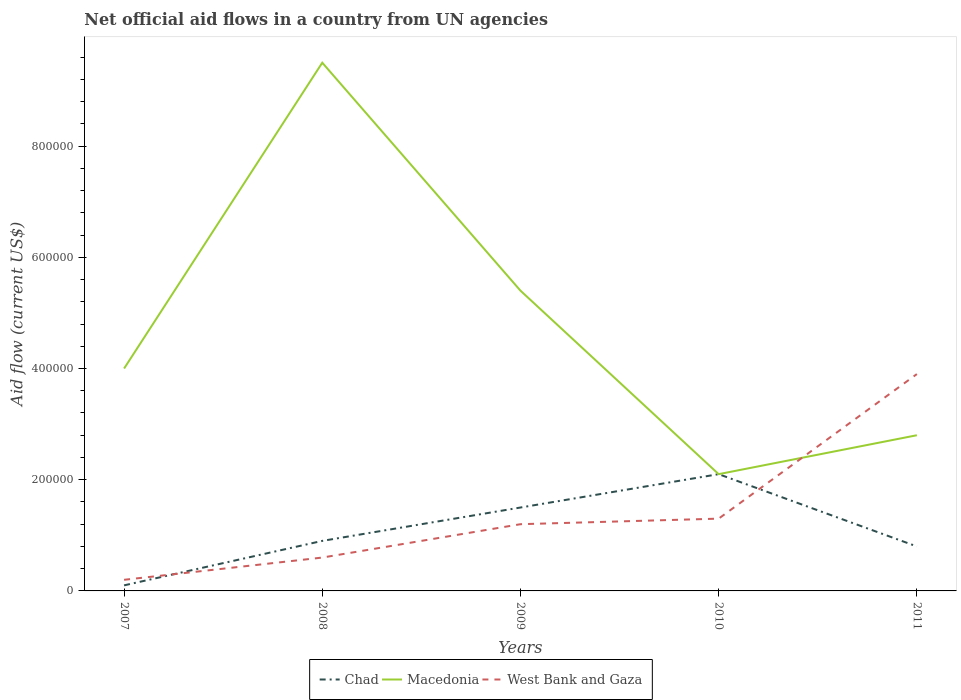How many different coloured lines are there?
Provide a short and direct response. 3. Does the line corresponding to Macedonia intersect with the line corresponding to Chad?
Provide a succinct answer. Yes. Is the number of lines equal to the number of legend labels?
Your answer should be compact. Yes. Across all years, what is the maximum net official aid flow in West Bank and Gaza?
Make the answer very short. 2.00e+04. In which year was the net official aid flow in Chad maximum?
Your answer should be compact. 2007. What is the total net official aid flow in West Bank and Gaza in the graph?
Your answer should be compact. -2.60e+05. What is the difference between the highest and the second highest net official aid flow in West Bank and Gaza?
Make the answer very short. 3.70e+05. What is the difference between the highest and the lowest net official aid flow in Chad?
Your response must be concise. 2. Is the net official aid flow in Chad strictly greater than the net official aid flow in Macedonia over the years?
Keep it short and to the point. No. What is the difference between two consecutive major ticks on the Y-axis?
Provide a short and direct response. 2.00e+05. Are the values on the major ticks of Y-axis written in scientific E-notation?
Ensure brevity in your answer.  No. Does the graph contain grids?
Provide a short and direct response. No. How many legend labels are there?
Provide a short and direct response. 3. How are the legend labels stacked?
Give a very brief answer. Horizontal. What is the title of the graph?
Offer a very short reply. Net official aid flows in a country from UN agencies. Does "Guyana" appear as one of the legend labels in the graph?
Your answer should be very brief. No. What is the Aid flow (current US$) of Chad in 2007?
Give a very brief answer. 10000. What is the Aid flow (current US$) of Macedonia in 2007?
Your response must be concise. 4.00e+05. What is the Aid flow (current US$) of West Bank and Gaza in 2007?
Give a very brief answer. 2.00e+04. What is the Aid flow (current US$) in Chad in 2008?
Your answer should be very brief. 9.00e+04. What is the Aid flow (current US$) of Macedonia in 2008?
Offer a very short reply. 9.50e+05. What is the Aid flow (current US$) of Chad in 2009?
Ensure brevity in your answer.  1.50e+05. What is the Aid flow (current US$) in Macedonia in 2009?
Keep it short and to the point. 5.40e+05. What is the Aid flow (current US$) in West Bank and Gaza in 2009?
Provide a succinct answer. 1.20e+05. What is the Aid flow (current US$) in Chad in 2010?
Your answer should be very brief. 2.10e+05. What is the Aid flow (current US$) in West Bank and Gaza in 2010?
Give a very brief answer. 1.30e+05. What is the Aid flow (current US$) of Chad in 2011?
Your answer should be compact. 8.00e+04. What is the Aid flow (current US$) of Macedonia in 2011?
Your answer should be very brief. 2.80e+05. What is the Aid flow (current US$) of West Bank and Gaza in 2011?
Your answer should be very brief. 3.90e+05. Across all years, what is the maximum Aid flow (current US$) in Chad?
Offer a very short reply. 2.10e+05. Across all years, what is the maximum Aid flow (current US$) in Macedonia?
Ensure brevity in your answer.  9.50e+05. Across all years, what is the maximum Aid flow (current US$) of West Bank and Gaza?
Ensure brevity in your answer.  3.90e+05. Across all years, what is the minimum Aid flow (current US$) in Chad?
Your response must be concise. 10000. Across all years, what is the minimum Aid flow (current US$) in Macedonia?
Provide a succinct answer. 2.10e+05. Across all years, what is the minimum Aid flow (current US$) in West Bank and Gaza?
Provide a short and direct response. 2.00e+04. What is the total Aid flow (current US$) in Chad in the graph?
Keep it short and to the point. 5.40e+05. What is the total Aid flow (current US$) in Macedonia in the graph?
Ensure brevity in your answer.  2.38e+06. What is the total Aid flow (current US$) in West Bank and Gaza in the graph?
Offer a very short reply. 7.20e+05. What is the difference between the Aid flow (current US$) of Chad in 2007 and that in 2008?
Keep it short and to the point. -8.00e+04. What is the difference between the Aid flow (current US$) of Macedonia in 2007 and that in 2008?
Your answer should be compact. -5.50e+05. What is the difference between the Aid flow (current US$) of Macedonia in 2007 and that in 2009?
Give a very brief answer. -1.40e+05. What is the difference between the Aid flow (current US$) in West Bank and Gaza in 2007 and that in 2009?
Your answer should be compact. -1.00e+05. What is the difference between the Aid flow (current US$) in Macedonia in 2007 and that in 2010?
Your answer should be compact. 1.90e+05. What is the difference between the Aid flow (current US$) of Chad in 2007 and that in 2011?
Make the answer very short. -7.00e+04. What is the difference between the Aid flow (current US$) in West Bank and Gaza in 2007 and that in 2011?
Your answer should be compact. -3.70e+05. What is the difference between the Aid flow (current US$) of Chad in 2008 and that in 2009?
Your response must be concise. -6.00e+04. What is the difference between the Aid flow (current US$) in Macedonia in 2008 and that in 2009?
Make the answer very short. 4.10e+05. What is the difference between the Aid flow (current US$) in Chad in 2008 and that in 2010?
Provide a succinct answer. -1.20e+05. What is the difference between the Aid flow (current US$) of Macedonia in 2008 and that in 2010?
Provide a short and direct response. 7.40e+05. What is the difference between the Aid flow (current US$) of Chad in 2008 and that in 2011?
Your answer should be compact. 10000. What is the difference between the Aid flow (current US$) in Macedonia in 2008 and that in 2011?
Keep it short and to the point. 6.70e+05. What is the difference between the Aid flow (current US$) in West Bank and Gaza in 2008 and that in 2011?
Your answer should be very brief. -3.30e+05. What is the difference between the Aid flow (current US$) in Macedonia in 2009 and that in 2011?
Offer a very short reply. 2.60e+05. What is the difference between the Aid flow (current US$) in Chad in 2007 and the Aid flow (current US$) in Macedonia in 2008?
Make the answer very short. -9.40e+05. What is the difference between the Aid flow (current US$) of Chad in 2007 and the Aid flow (current US$) of Macedonia in 2009?
Provide a succinct answer. -5.30e+05. What is the difference between the Aid flow (current US$) in Chad in 2007 and the Aid flow (current US$) in West Bank and Gaza in 2010?
Give a very brief answer. -1.20e+05. What is the difference between the Aid flow (current US$) of Macedonia in 2007 and the Aid flow (current US$) of West Bank and Gaza in 2010?
Offer a very short reply. 2.70e+05. What is the difference between the Aid flow (current US$) in Chad in 2007 and the Aid flow (current US$) in Macedonia in 2011?
Keep it short and to the point. -2.70e+05. What is the difference between the Aid flow (current US$) of Chad in 2007 and the Aid flow (current US$) of West Bank and Gaza in 2011?
Give a very brief answer. -3.80e+05. What is the difference between the Aid flow (current US$) in Macedonia in 2007 and the Aid flow (current US$) in West Bank and Gaza in 2011?
Make the answer very short. 10000. What is the difference between the Aid flow (current US$) of Chad in 2008 and the Aid flow (current US$) of Macedonia in 2009?
Offer a terse response. -4.50e+05. What is the difference between the Aid flow (current US$) of Macedonia in 2008 and the Aid flow (current US$) of West Bank and Gaza in 2009?
Provide a succinct answer. 8.30e+05. What is the difference between the Aid flow (current US$) in Chad in 2008 and the Aid flow (current US$) in West Bank and Gaza in 2010?
Offer a very short reply. -4.00e+04. What is the difference between the Aid flow (current US$) in Macedonia in 2008 and the Aid flow (current US$) in West Bank and Gaza in 2010?
Offer a terse response. 8.20e+05. What is the difference between the Aid flow (current US$) in Macedonia in 2008 and the Aid flow (current US$) in West Bank and Gaza in 2011?
Your answer should be compact. 5.60e+05. What is the difference between the Aid flow (current US$) of Chad in 2009 and the Aid flow (current US$) of Macedonia in 2010?
Provide a short and direct response. -6.00e+04. What is the difference between the Aid flow (current US$) in Chad in 2009 and the Aid flow (current US$) in Macedonia in 2011?
Your answer should be very brief. -1.30e+05. What is the difference between the Aid flow (current US$) of Chad in 2010 and the Aid flow (current US$) of Macedonia in 2011?
Provide a short and direct response. -7.00e+04. What is the average Aid flow (current US$) of Chad per year?
Keep it short and to the point. 1.08e+05. What is the average Aid flow (current US$) of Macedonia per year?
Ensure brevity in your answer.  4.76e+05. What is the average Aid flow (current US$) of West Bank and Gaza per year?
Provide a short and direct response. 1.44e+05. In the year 2007, what is the difference between the Aid flow (current US$) of Chad and Aid flow (current US$) of Macedonia?
Your answer should be compact. -3.90e+05. In the year 2007, what is the difference between the Aid flow (current US$) in Macedonia and Aid flow (current US$) in West Bank and Gaza?
Offer a terse response. 3.80e+05. In the year 2008, what is the difference between the Aid flow (current US$) in Chad and Aid flow (current US$) in Macedonia?
Give a very brief answer. -8.60e+05. In the year 2008, what is the difference between the Aid flow (current US$) of Macedonia and Aid flow (current US$) of West Bank and Gaza?
Ensure brevity in your answer.  8.90e+05. In the year 2009, what is the difference between the Aid flow (current US$) of Chad and Aid flow (current US$) of Macedonia?
Ensure brevity in your answer.  -3.90e+05. In the year 2010, what is the difference between the Aid flow (current US$) in Chad and Aid flow (current US$) in Macedonia?
Offer a terse response. 0. In the year 2010, what is the difference between the Aid flow (current US$) of Chad and Aid flow (current US$) of West Bank and Gaza?
Offer a terse response. 8.00e+04. In the year 2010, what is the difference between the Aid flow (current US$) of Macedonia and Aid flow (current US$) of West Bank and Gaza?
Provide a short and direct response. 8.00e+04. In the year 2011, what is the difference between the Aid flow (current US$) of Chad and Aid flow (current US$) of Macedonia?
Give a very brief answer. -2.00e+05. In the year 2011, what is the difference between the Aid flow (current US$) in Chad and Aid flow (current US$) in West Bank and Gaza?
Your answer should be compact. -3.10e+05. What is the ratio of the Aid flow (current US$) of Chad in 2007 to that in 2008?
Provide a succinct answer. 0.11. What is the ratio of the Aid flow (current US$) of Macedonia in 2007 to that in 2008?
Keep it short and to the point. 0.42. What is the ratio of the Aid flow (current US$) in Chad in 2007 to that in 2009?
Your response must be concise. 0.07. What is the ratio of the Aid flow (current US$) in Macedonia in 2007 to that in 2009?
Keep it short and to the point. 0.74. What is the ratio of the Aid flow (current US$) in Chad in 2007 to that in 2010?
Ensure brevity in your answer.  0.05. What is the ratio of the Aid flow (current US$) in Macedonia in 2007 to that in 2010?
Offer a terse response. 1.9. What is the ratio of the Aid flow (current US$) of West Bank and Gaza in 2007 to that in 2010?
Offer a terse response. 0.15. What is the ratio of the Aid flow (current US$) of Macedonia in 2007 to that in 2011?
Your response must be concise. 1.43. What is the ratio of the Aid flow (current US$) in West Bank and Gaza in 2007 to that in 2011?
Your response must be concise. 0.05. What is the ratio of the Aid flow (current US$) of Chad in 2008 to that in 2009?
Your answer should be very brief. 0.6. What is the ratio of the Aid flow (current US$) of Macedonia in 2008 to that in 2009?
Provide a short and direct response. 1.76. What is the ratio of the Aid flow (current US$) of Chad in 2008 to that in 2010?
Make the answer very short. 0.43. What is the ratio of the Aid flow (current US$) of Macedonia in 2008 to that in 2010?
Provide a short and direct response. 4.52. What is the ratio of the Aid flow (current US$) in West Bank and Gaza in 2008 to that in 2010?
Provide a succinct answer. 0.46. What is the ratio of the Aid flow (current US$) of Chad in 2008 to that in 2011?
Provide a succinct answer. 1.12. What is the ratio of the Aid flow (current US$) in Macedonia in 2008 to that in 2011?
Make the answer very short. 3.39. What is the ratio of the Aid flow (current US$) in West Bank and Gaza in 2008 to that in 2011?
Make the answer very short. 0.15. What is the ratio of the Aid flow (current US$) of Chad in 2009 to that in 2010?
Offer a terse response. 0.71. What is the ratio of the Aid flow (current US$) of Macedonia in 2009 to that in 2010?
Offer a very short reply. 2.57. What is the ratio of the Aid flow (current US$) in West Bank and Gaza in 2009 to that in 2010?
Provide a succinct answer. 0.92. What is the ratio of the Aid flow (current US$) of Chad in 2009 to that in 2011?
Keep it short and to the point. 1.88. What is the ratio of the Aid flow (current US$) in Macedonia in 2009 to that in 2011?
Offer a terse response. 1.93. What is the ratio of the Aid flow (current US$) of West Bank and Gaza in 2009 to that in 2011?
Provide a succinct answer. 0.31. What is the ratio of the Aid flow (current US$) of Chad in 2010 to that in 2011?
Provide a short and direct response. 2.62. What is the ratio of the Aid flow (current US$) of Macedonia in 2010 to that in 2011?
Offer a very short reply. 0.75. What is the ratio of the Aid flow (current US$) of West Bank and Gaza in 2010 to that in 2011?
Provide a short and direct response. 0.33. What is the difference between the highest and the second highest Aid flow (current US$) of Macedonia?
Keep it short and to the point. 4.10e+05. What is the difference between the highest and the second highest Aid flow (current US$) of West Bank and Gaza?
Keep it short and to the point. 2.60e+05. What is the difference between the highest and the lowest Aid flow (current US$) in Chad?
Give a very brief answer. 2.00e+05. What is the difference between the highest and the lowest Aid flow (current US$) in Macedonia?
Offer a very short reply. 7.40e+05. What is the difference between the highest and the lowest Aid flow (current US$) in West Bank and Gaza?
Make the answer very short. 3.70e+05. 